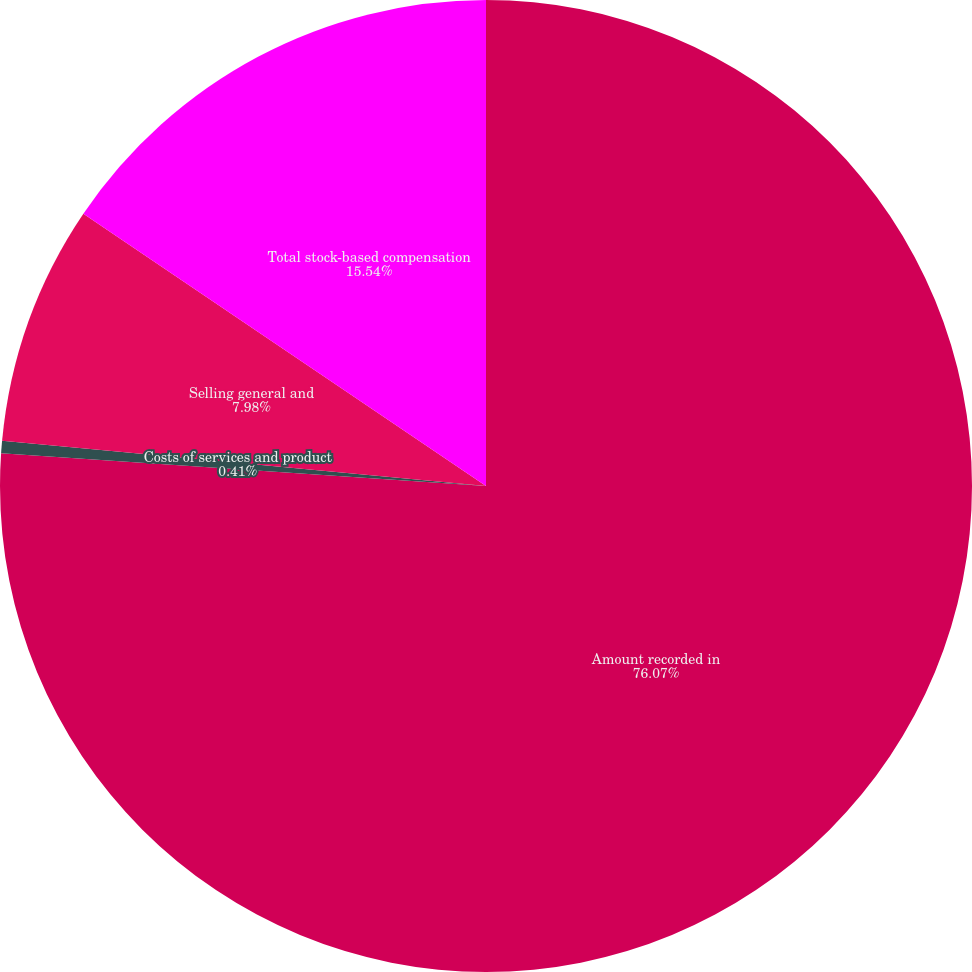Convert chart to OTSL. <chart><loc_0><loc_0><loc_500><loc_500><pie_chart><fcel>Amount recorded in<fcel>Costs of services and product<fcel>Selling general and<fcel>Total stock-based compensation<nl><fcel>76.07%<fcel>0.41%<fcel>7.98%<fcel>15.54%<nl></chart> 